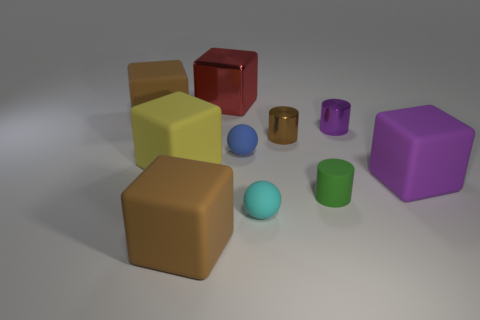Are there any brown cylinders made of the same material as the small green object?
Your answer should be very brief. No. The small rubber cylinder has what color?
Your response must be concise. Green. There is a brown matte cube behind the big cube that is in front of the rubber sphere in front of the big purple thing; what is its size?
Offer a terse response. Large. What number of other objects are there of the same shape as the tiny blue object?
Provide a short and direct response. 1. What color is the thing that is to the left of the tiny cyan sphere and on the right side of the red shiny block?
Keep it short and to the point. Blue. Is the color of the cube in front of the matte cylinder the same as the small rubber cylinder?
Give a very brief answer. No. What number of cylinders are either small cyan rubber things or big yellow objects?
Make the answer very short. 0. What is the shape of the big brown object that is behind the tiny blue rubber sphere?
Give a very brief answer. Cube. There is a large rubber cube right of the big brown rubber object that is in front of the large rubber object behind the big yellow cube; what color is it?
Keep it short and to the point. Purple. Is the red block made of the same material as the purple cube?
Your answer should be very brief. No. 